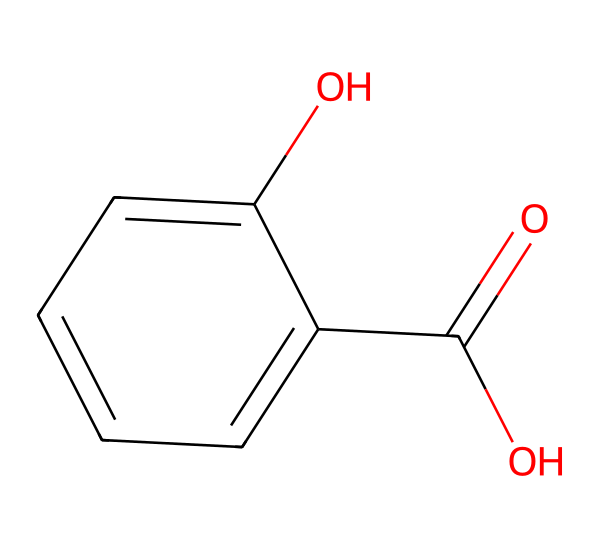What is the molecular formula of salicylic acid? To determine the molecular formula, we can count the number of each type of atom present in the SMILES representation. The chemical structure contains 7 carbon (C) atoms, 6 hydrogen (H) atoms, and 3 oxygen (O) atoms. Therefore, the molecular formula is C7H6O3.
Answer: C7H6O3 How many hydrogen atoms are present in salicylic acid? By analyzing the SMILES representation, we see that there are a total of 6 hydrogen atoms connected to the carbon backbone and functional groups of the molecule.
Answer: 6 What type of functional groups are found in salicylic acid? Observing the structure, salicylic acid contains a carboxylic acid group (-COOH) and a hydroxyl group (-OH). Both of these functional groups are essential for its properties.
Answer: carboxylic acid and hydroxyl How many rings are present in salicylic acid? The chemical structure lacks any cyclic formations, indicating there are no rings present in salicylic acid. The molecule is predominantly linear with a benzene ring and supports different functional groups.
Answer: 0 What is the main reason salicylic acid is effective for acne treatment? Salicylic acid penetrates the pores and helps to exfoliate the skin, which leads to the removal of dead skin cells and excess oil. This effectively reduces acne formation and unclogs pores.
Answer: exfoliation 